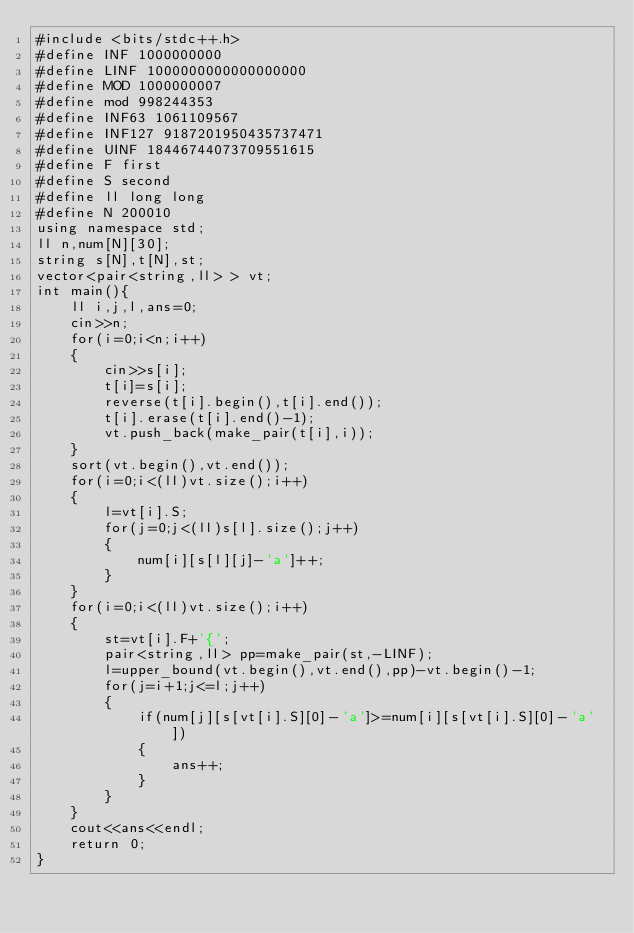<code> <loc_0><loc_0><loc_500><loc_500><_C++_>#include <bits/stdc++.h>
#define INF 1000000000
#define LINF 1000000000000000000
#define MOD 1000000007
#define mod 998244353
#define INF63 1061109567
#define INF127 9187201950435737471
#define UINF 18446744073709551615
#define F first
#define S second
#define ll long long
#define N 200010
using namespace std;
ll n,num[N][30];
string s[N],t[N],st;
vector<pair<string,ll> > vt;
int main(){
	ll i,j,l,ans=0;
	cin>>n;
	for(i=0;i<n;i++)
	{
		cin>>s[i];
		t[i]=s[i];
		reverse(t[i].begin(),t[i].end());
		t[i].erase(t[i].end()-1);
		vt.push_back(make_pair(t[i],i));
	}
	sort(vt.begin(),vt.end());
	for(i=0;i<(ll)vt.size();i++)
	{
		l=vt[i].S;
		for(j=0;j<(ll)s[l].size();j++)
		{
			num[i][s[l][j]-'a']++;
		}
	}
	for(i=0;i<(ll)vt.size();i++)
	{
		st=vt[i].F+'{';
		pair<string,ll> pp=make_pair(st,-LINF);
		l=upper_bound(vt.begin(),vt.end(),pp)-vt.begin()-1;
		for(j=i+1;j<=l;j++)
		{
			if(num[j][s[vt[i].S][0]-'a']>=num[i][s[vt[i].S][0]-'a'])
			{
				ans++;
			}
		}
	}
	cout<<ans<<endl;
	return 0;
}</code> 